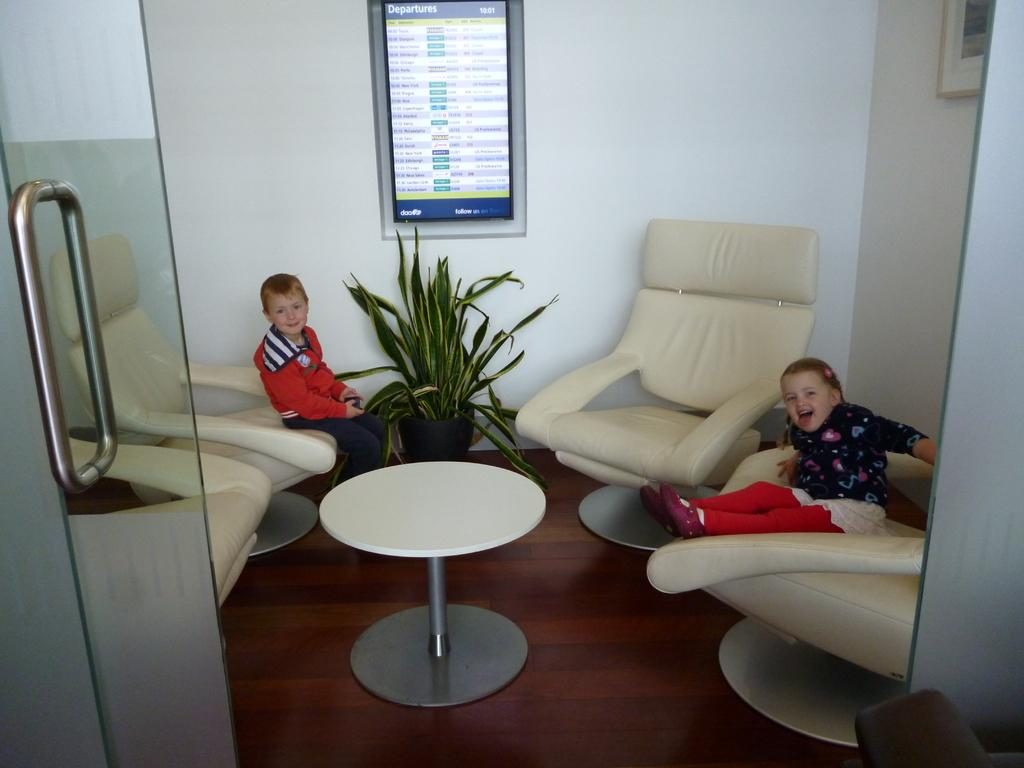What type of door is visible in the image? The image features a glass door. What is the baby girl doing on the sofa? The baby girl is sitting on a sofa and smiling. Who else is present in the image? There is a boy in the image. What is the boy doing in the image? The boy is sitting on a sofa. How does the baby girl help the flock of birds in the image? There are no birds present in the image, so the baby girl cannot help any flock of birds. 